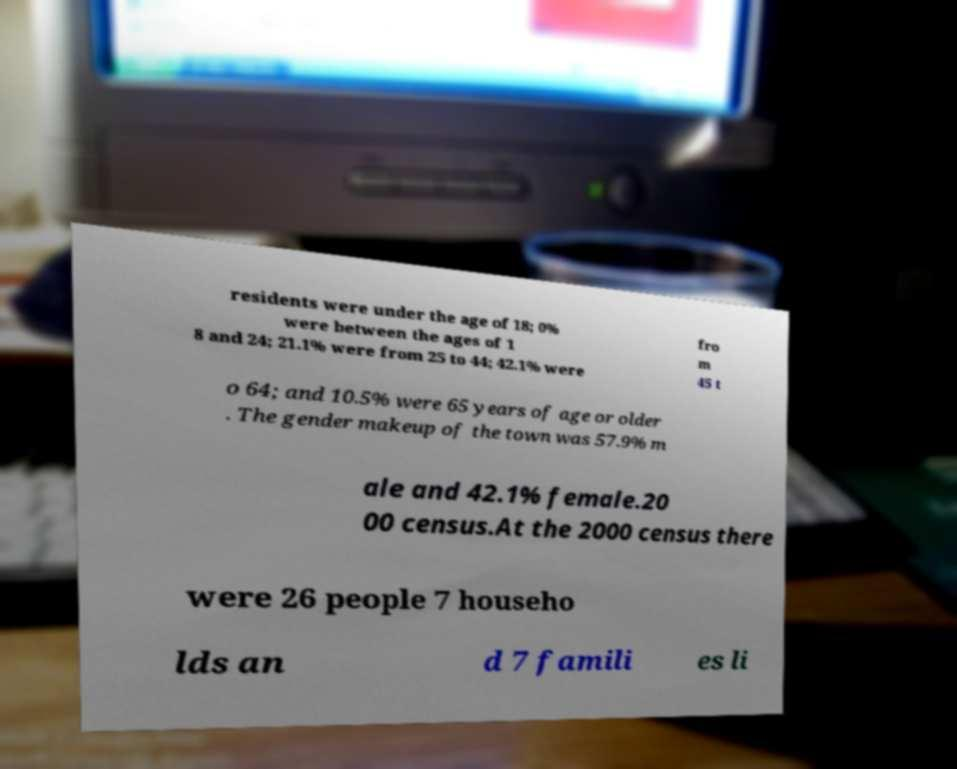Can you read and provide the text displayed in the image?This photo seems to have some interesting text. Can you extract and type it out for me? residents were under the age of 18; 0% were between the ages of 1 8 and 24; 21.1% were from 25 to 44; 42.1% were fro m 45 t o 64; and 10.5% were 65 years of age or older . The gender makeup of the town was 57.9% m ale and 42.1% female.20 00 census.At the 2000 census there were 26 people 7 househo lds an d 7 famili es li 